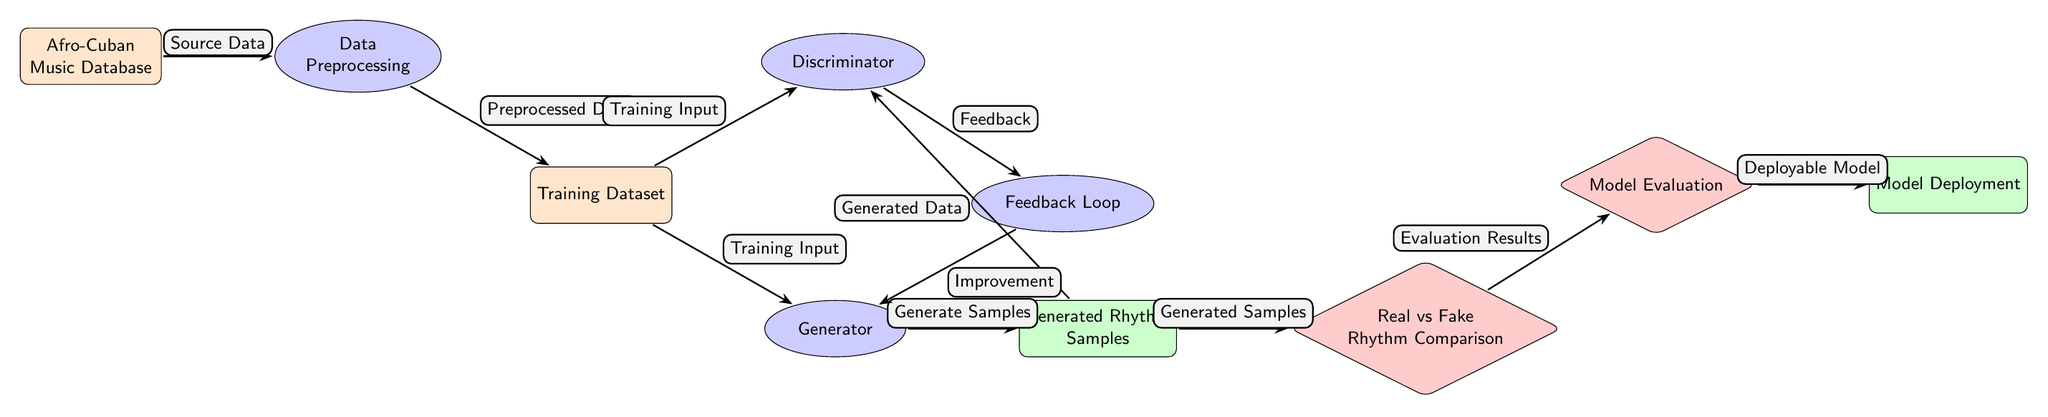What is the input source for the Data Preprocessing step? The input source for the Data Preprocessing step is the Afro-Cuban Music Database, indicated by the directed edge labeled "Source Data" leading into the Data Preprocessing node.
Answer: Afro-Cuban Music Database How many processes are represented in the diagram? There are four processes represented in the diagram: Data Preprocessing, Generator, Discriminator, and Feedback Loop. This can be counted by identifying the nodes categorized with the 'process' style.
Answer: 4 What does the Discriminator use as input? The Discriminator uses the Training Dataset as input, as indicated by the directed edge labeled "Training Input" that connects from the Training Dataset node to the Discriminator process node.
Answer: Training Dataset What feedback is provided to improve the Generator? The feedback provided to improve the Generator comes from the Discriminator, as indicated by the directed edge labeled "Feedback" leading from the Discriminator to the Feedback Loop.
Answer: Feedback What is the output of the Generator? The output of the Generator is the Generated Rhythm Samples, which is indicated by the directed edge labeled "Generate Samples" that connects from the Generator process to the Generated Rhythm Samples output node.
Answer: Generated Rhythm Samples How many evaluation steps are present in the diagram? There are two evaluation steps present in the diagram: Real vs Fake Rhythm Comparison and Model Evaluation, which can be identified by counting the evaluation nodes labeled with the 'evaluation' style.
Answer: 2 What is done with the Evaluation Results? The Evaluation Results are used in the Model Evaluation step, as indicated by the directed edge labeled "Evaluation Results" leading from the Real vs Fake Rhythm Comparison to the Model Evaluation node.
Answer: Model Evaluation What is the final output of the diagram? The final output of the diagram is the Deployable Model, which is represented by the output node furthest to the right labeled with that name, connected by a directed edge from the Model Evaluation node.
Answer: Deployable Model What type of data does the Generator produce? The Generator produces generated data, specifically referred to as Generated Rhythm Samples, as indicated by the directed edge that flows from the Generator to the Generated Rhythm Samples output node.
Answer: Generated Rhythm Samples 